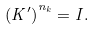<formula> <loc_0><loc_0><loc_500><loc_500>\left ( K ^ { \prime } \right ) ^ { n _ { k } } = I .</formula> 